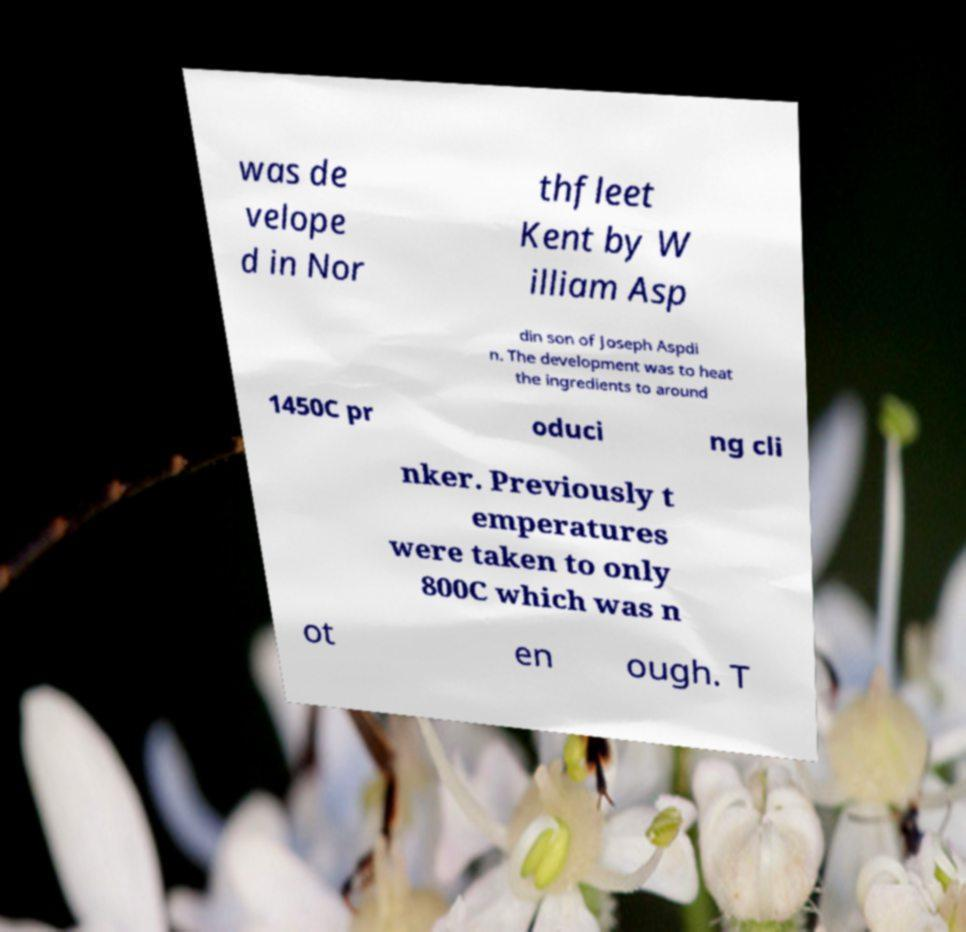I need the written content from this picture converted into text. Can you do that? was de velope d in Nor thfleet Kent by W illiam Asp din son of Joseph Aspdi n. The development was to heat the ingredients to around 1450C pr oduci ng cli nker. Previously t emperatures were taken to only 800C which was n ot en ough. T 